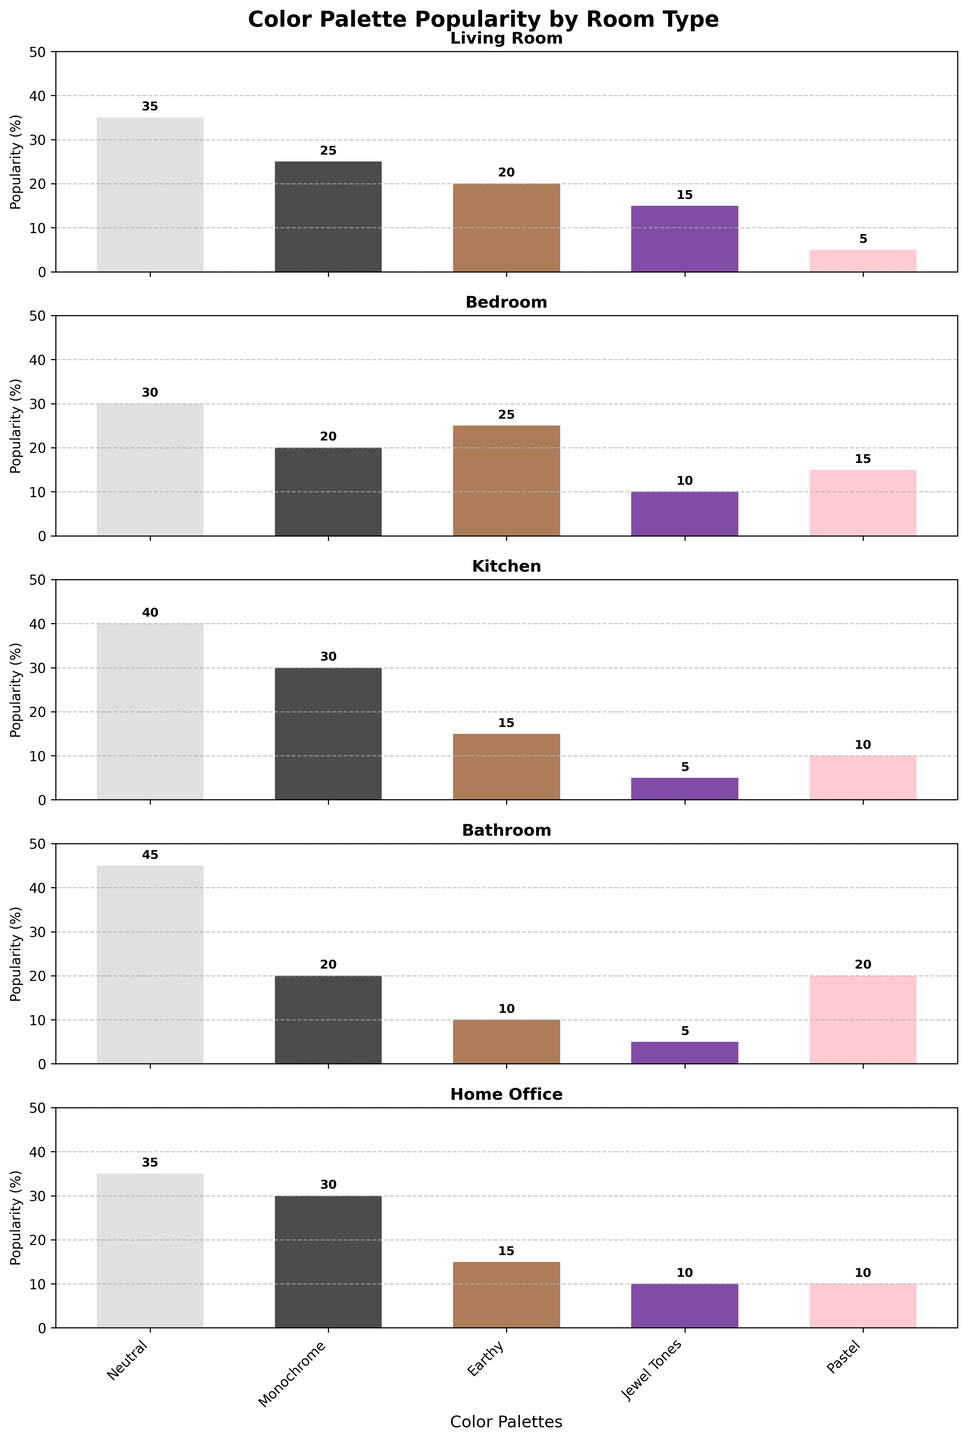Which room type shows the highest popularity of neutral color palettes? According to the figure, we need to find the highest bar in the 'Neutral' category across all room types. The Bathroom has the highest popularity for neutral colors, at 45%.
Answer: Bathroom What is the total popularity percentage for the Earthy color palette across all room types? To find the total, sum the Earthy color palette values from all room types: 20 (Living Room) + 25 (Bedroom) + 15 (Kitchen) + 10 (Bathroom) + 15 (Home Office) = 85
Answer: 85 Which color palette is the least popular in the Living Room? Looking at the Living Room subplot, we see that the Pastel color palette has the lowest value, at 5%.
Answer: Pastel How does the popularity of Monochrome in the Kitchen compare to its popularity in the Bedroom? The figure shows that the Monochrome palette has 30% popularity in the Kitchen and 20% in the Bedroom. Therefore, it is 10% more popular in the Kitchen.
Answer: Kitchen has 10% more What's the average popularity of Jewel Tones across all room types? To find the average, sum the Jewel Tones values and divide by the number of room types: (15+10+5+5+10)/5 = 45/5 = 9
Answer: 9 In which room is the Pastel color palette most popular? Checking all the subplots, the Bathroom has the highest bar for Pastels at 20%.
Answer: Bathroom How does the popularity of Neutral colors in the Home Office compare to that in the Living Room? Both the Home Office and the Living Room have the same popularity for Neutral colors, at 35%.
Answer: Equal popularity Which room type has the most evenly distributed popularity across all color palettes? From the figure, analyze the bars to see which room's bars are closest in height. The Bedroom has more evenly distributed popularity across different color palettes compared to others.
Answer: Bedroom 